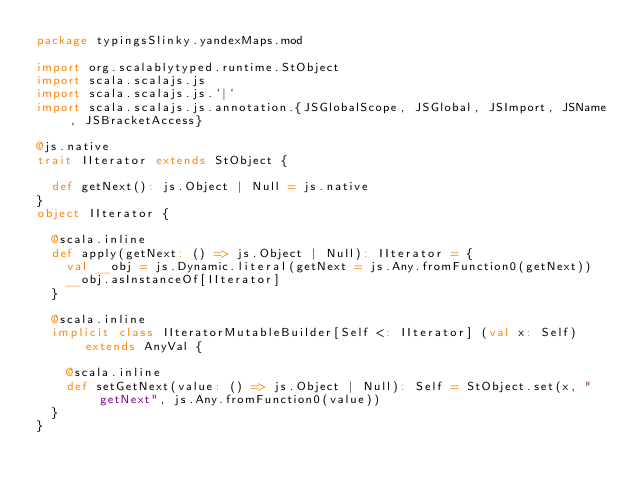Convert code to text. <code><loc_0><loc_0><loc_500><loc_500><_Scala_>package typingsSlinky.yandexMaps.mod

import org.scalablytyped.runtime.StObject
import scala.scalajs.js
import scala.scalajs.js.`|`
import scala.scalajs.js.annotation.{JSGlobalScope, JSGlobal, JSImport, JSName, JSBracketAccess}

@js.native
trait IIterator extends StObject {
  
  def getNext(): js.Object | Null = js.native
}
object IIterator {
  
  @scala.inline
  def apply(getNext: () => js.Object | Null): IIterator = {
    val __obj = js.Dynamic.literal(getNext = js.Any.fromFunction0(getNext))
    __obj.asInstanceOf[IIterator]
  }
  
  @scala.inline
  implicit class IIteratorMutableBuilder[Self <: IIterator] (val x: Self) extends AnyVal {
    
    @scala.inline
    def setGetNext(value: () => js.Object | Null): Self = StObject.set(x, "getNext", js.Any.fromFunction0(value))
  }
}
</code> 